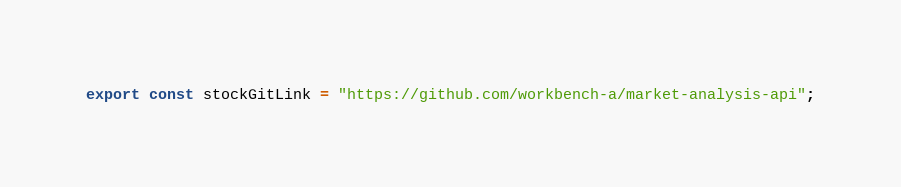Convert code to text. <code><loc_0><loc_0><loc_500><loc_500><_JavaScript_>export const stockGitLink = "https://github.com/workbench-a/market-analysis-api";</code> 